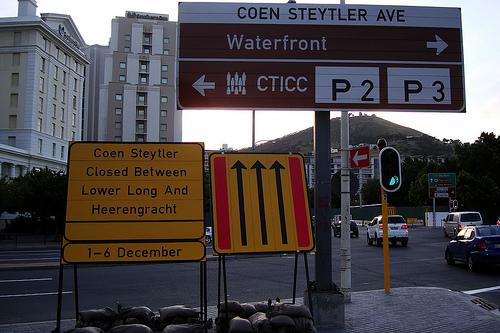Question: what is on the yellow and orange sign?
Choices:
A. Caution.
B. Arrows.
C. Road Work Ahead.
D. A phone number.
Answer with the letter. Answer: B Question: where was the picture taken?
Choices:
A. In the car.
B. At an intersection.
C. At the club.
D. In her house.
Answer with the letter. Answer: B Question: what dates in December are on the left sign?
Choices:
A. 4-10.
B. 1-6.
C. 13-30.
D. 1-30.
Answer with the letter. Answer: B Question: what is on the right side of the picture behind the signs?
Choices:
A. A mountain.
B. A river.
C. A building.
D. A parking lot.
Answer with the letter. Answer: A 